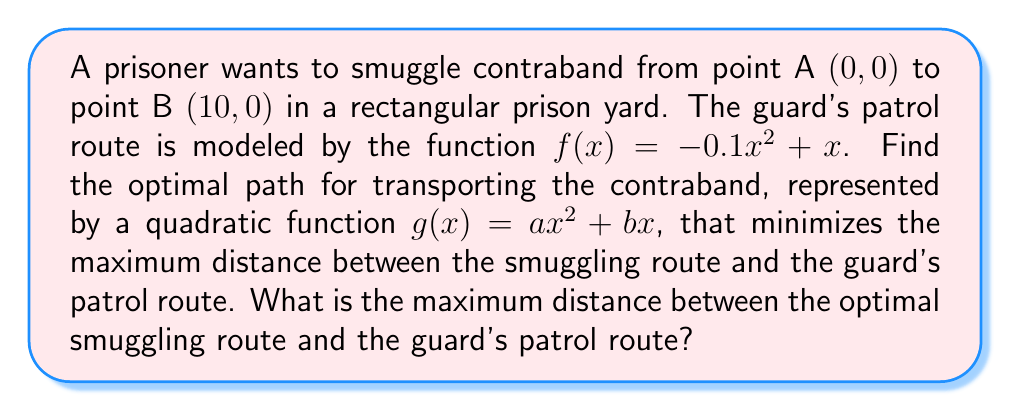What is the answer to this math problem? To solve this problem, we need to follow these steps:

1) The guard's patrol route is given by $f(x) = -0.1x^2 + x$.

2) We're looking for a quadratic function $g(x) = ax^2 + bx$ that minimizes the maximum distance from $f(x)$.

3) The distance between the two functions at any point x is given by $|f(x) - g(x)|$.

4) To minimize the maximum distance, we want $g(x)$ to be as close to $f(x)$ as possible at all points.

5) The optimal $g(x)$ will occur when the maximum distance above $f(x)$ equals the maximum distance below $f(x)$. This happens when $g(x)$ is the average of $f(x)$ and a vertical reflection of $f(x)$.

6) The reflection of $f(x)$ about the x-axis is $-f(x) = 0.1x^2 - x$.

7) Therefore, the optimal $g(x)$ is:

   $g(x) = \frac{f(x) + (-f(x))}{2} = \frac{(-0.1x^2 + x) + (0.1x^2 - x)}{2} = 0$

8) So, the optimal smuggling route is along the x-axis: $g(x) = 0$.

9) The maximum distance between $g(x)$ and $f(x)$ occurs at the vertex of $f(x)$.

10) To find the vertex, we calculate:
    $x = -\frac{b}{2a} = -\frac{1}{2(-0.1)} = 5$

11) The maximum distance is:
    $|f(5) - g(5)| = |(-0.1(5)^2 + 5) - 0| = |-2.5 + 5| = 2.5$

Therefore, the maximum distance between the optimal smuggling route and the guard's patrol route is 2.5 units.
Answer: The maximum distance between the optimal smuggling route and the guard's patrol route is 2.5 units. 